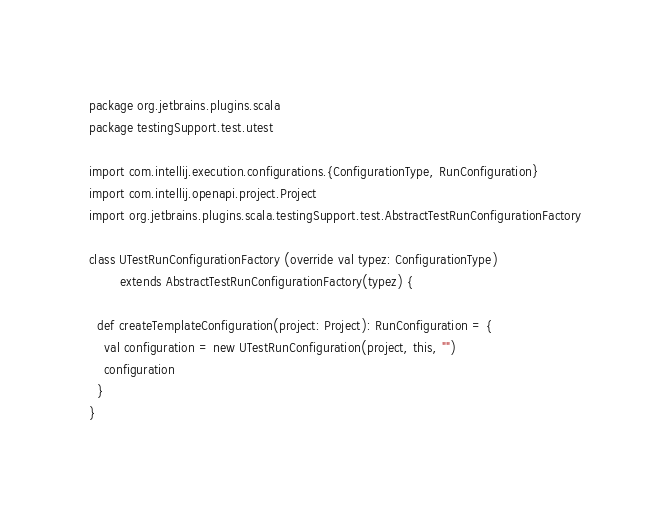Convert code to text. <code><loc_0><loc_0><loc_500><loc_500><_Scala_>package org.jetbrains.plugins.scala
package testingSupport.test.utest

import com.intellij.execution.configurations.{ConfigurationType, RunConfiguration}
import com.intellij.openapi.project.Project
import org.jetbrains.plugins.scala.testingSupport.test.AbstractTestRunConfigurationFactory

class UTestRunConfigurationFactory (override val typez: ConfigurationType)
        extends AbstractTestRunConfigurationFactory(typez) {

  def createTemplateConfiguration(project: Project): RunConfiguration = {
    val configuration = new UTestRunConfiguration(project, this, "")
    configuration
  }
}</code> 